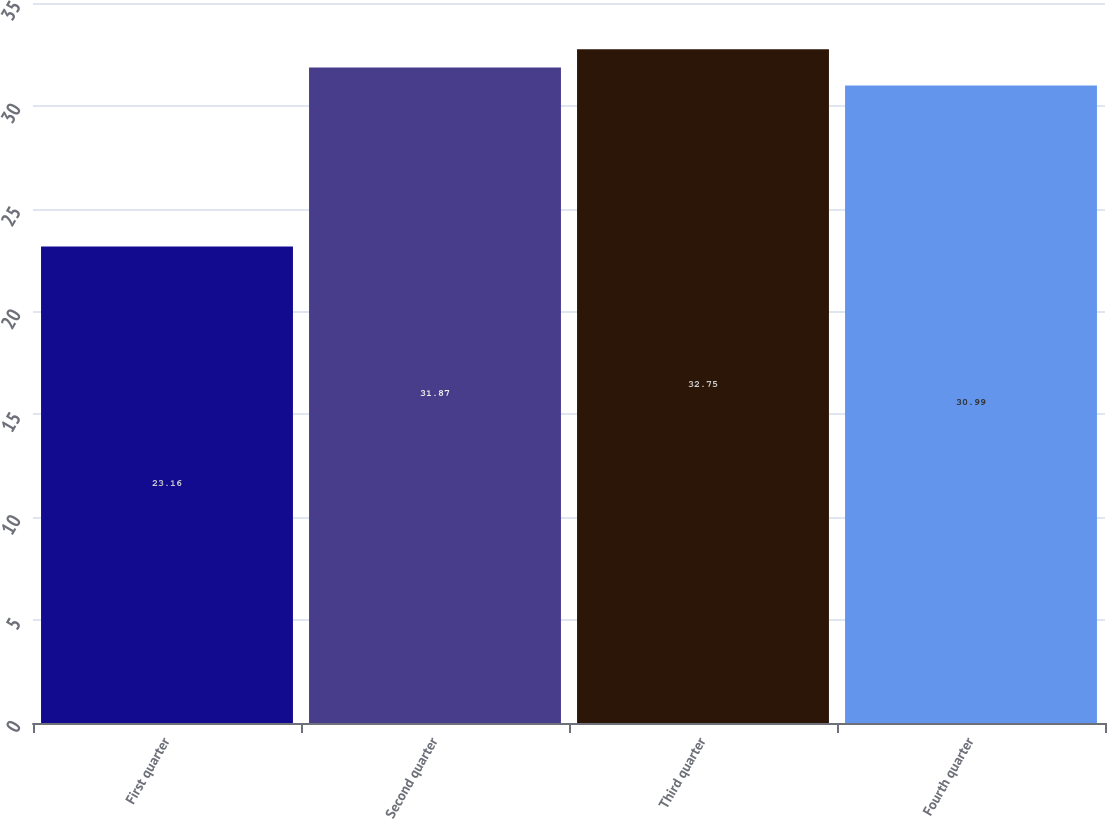Convert chart. <chart><loc_0><loc_0><loc_500><loc_500><bar_chart><fcel>First quarter<fcel>Second quarter<fcel>Third quarter<fcel>Fourth quarter<nl><fcel>23.16<fcel>31.87<fcel>32.75<fcel>30.99<nl></chart> 